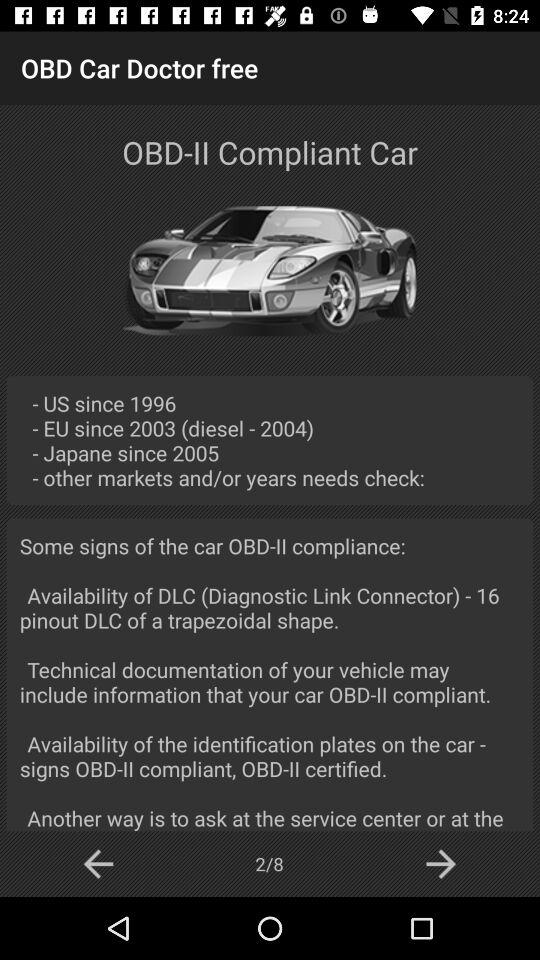How many slides in total are there? There are 8 slides in total. 